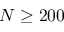Convert formula to latex. <formula><loc_0><loc_0><loc_500><loc_500>N \geq 2 0 0</formula> 